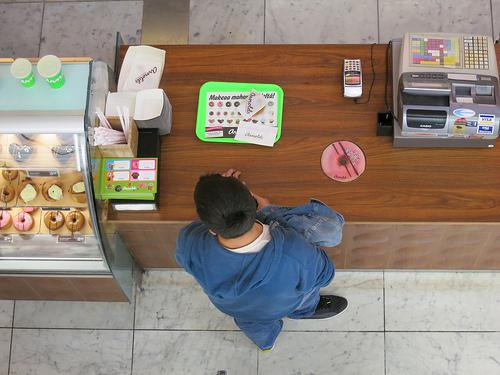Question: who is in front of counter?
Choices:
A. Woman.
B. Clerk.
C. Man.
D. Teen.
Answer with the letter. Answer: C Question: where is man?
Choices:
A. At the door.
B. In a store.
C. Front Counter.
D. At the airport.
Answer with the letter. Answer: C Question: what color man's jacket?
Choices:
A. Red.
B. Pink.
C. Blue.
D. Purple.
Answer with the letter. Answer: C Question: what is in case?
Choices:
A. Books.
B. Magazines.
C. Papers.
D. Donuts and Pastries.
Answer with the letter. Answer: D Question: what's on top display case?
Choices:
A. Trophy.
B. Cups.
C. Plates.
D. 2 green cups.
Answer with the letter. Answer: D 